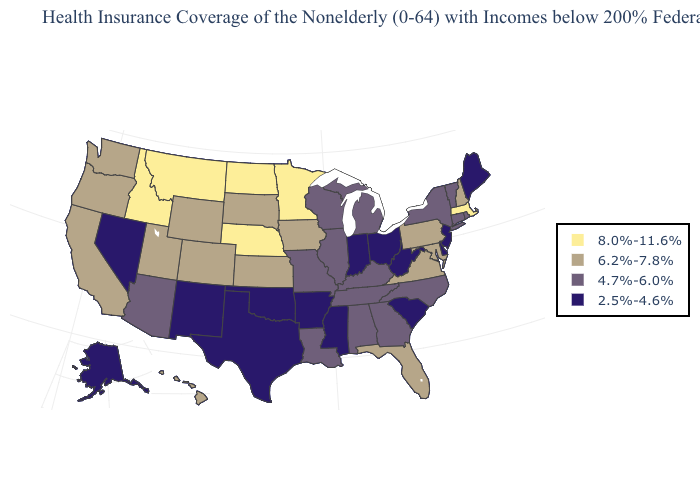What is the value of North Dakota?
Be succinct. 8.0%-11.6%. What is the value of Connecticut?
Concise answer only. 4.7%-6.0%. Name the states that have a value in the range 2.5%-4.6%?
Be succinct. Alaska, Arkansas, Delaware, Indiana, Maine, Mississippi, Nevada, New Jersey, New Mexico, Ohio, Oklahoma, South Carolina, Texas, West Virginia. Does Rhode Island have the lowest value in the USA?
Give a very brief answer. No. What is the highest value in the Northeast ?
Concise answer only. 8.0%-11.6%. Does South Dakota have a lower value than Massachusetts?
Keep it brief. Yes. What is the value of Michigan?
Answer briefly. 4.7%-6.0%. Among the states that border Virginia , does Tennessee have the lowest value?
Give a very brief answer. No. Which states hav the highest value in the Northeast?
Concise answer only. Massachusetts. How many symbols are there in the legend?
Concise answer only. 4. What is the value of North Carolina?
Give a very brief answer. 4.7%-6.0%. Name the states that have a value in the range 4.7%-6.0%?
Short answer required. Alabama, Arizona, Connecticut, Georgia, Illinois, Kentucky, Louisiana, Michigan, Missouri, New York, North Carolina, Rhode Island, Tennessee, Vermont, Wisconsin. Does Missouri have the lowest value in the MidWest?
Write a very short answer. No. Name the states that have a value in the range 8.0%-11.6%?
Concise answer only. Idaho, Massachusetts, Minnesota, Montana, Nebraska, North Dakota. What is the highest value in the USA?
Give a very brief answer. 8.0%-11.6%. 